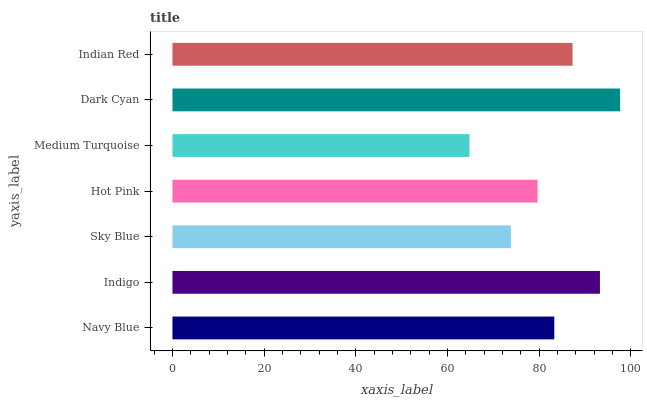Is Medium Turquoise the minimum?
Answer yes or no. Yes. Is Dark Cyan the maximum?
Answer yes or no. Yes. Is Indigo the minimum?
Answer yes or no. No. Is Indigo the maximum?
Answer yes or no. No. Is Indigo greater than Navy Blue?
Answer yes or no. Yes. Is Navy Blue less than Indigo?
Answer yes or no. Yes. Is Navy Blue greater than Indigo?
Answer yes or no. No. Is Indigo less than Navy Blue?
Answer yes or no. No. Is Navy Blue the high median?
Answer yes or no. Yes. Is Navy Blue the low median?
Answer yes or no. Yes. Is Indian Red the high median?
Answer yes or no. No. Is Sky Blue the low median?
Answer yes or no. No. 